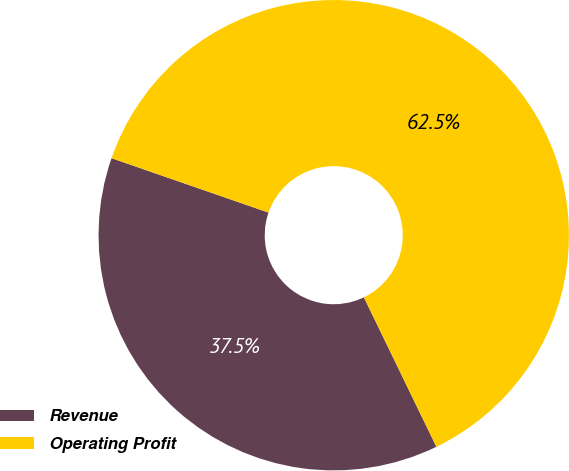<chart> <loc_0><loc_0><loc_500><loc_500><pie_chart><fcel>Revenue<fcel>Operating Profit<nl><fcel>37.5%<fcel>62.5%<nl></chart> 